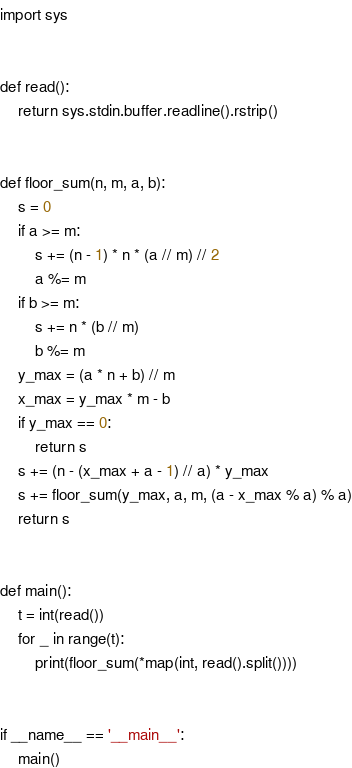<code> <loc_0><loc_0><loc_500><loc_500><_Python_>import sys


def read():
    return sys.stdin.buffer.readline().rstrip()


def floor_sum(n, m, a, b):
    s = 0
    if a >= m:
        s += (n - 1) * n * (a // m) // 2
        a %= m
    if b >= m:
        s += n * (b // m)
        b %= m
    y_max = (a * n + b) // m
    x_max = y_max * m - b
    if y_max == 0:
        return s
    s += (n - (x_max + a - 1) // a) * y_max
    s += floor_sum(y_max, a, m, (a - x_max % a) % a)
    return s


def main():
    t = int(read())
    for _ in range(t):
        print(floor_sum(*map(int, read().split())))


if __name__ == '__main__':
    main()
</code> 